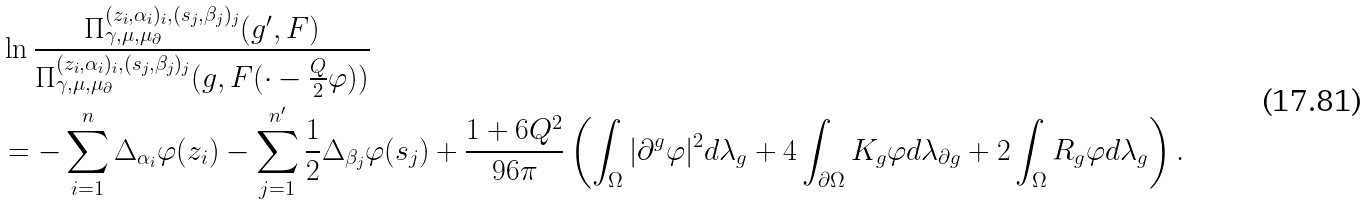<formula> <loc_0><loc_0><loc_500><loc_500>& \ln \frac { \Pi _ { \gamma , \mu , \mu _ { \partial } } ^ { ( z _ { i } , \alpha _ { i } ) _ { i } , ( s _ { j } , \beta _ { j } ) _ { j } } ( g ^ { \prime } , F ) } { \Pi _ { \gamma , \mu , \mu _ { \partial } } ^ { ( z _ { i } , \alpha _ { i } ) _ { i } , ( s _ { j } , \beta _ { j } ) _ { j } } ( g , F ( \cdot - \frac { Q } { 2 } \varphi ) ) } \\ & = - \sum _ { i = 1 } ^ { n } \Delta _ { \alpha _ { i } } \varphi ( z _ { i } ) - \sum _ { j = 1 } ^ { n ^ { \prime } } \frac { 1 } { 2 } \Delta _ { \beta _ { j } } \varphi ( s _ { j } ) + \frac { 1 + 6 Q ^ { 2 } } { 9 6 \pi } \left ( \int _ { \Omega } | \partial ^ { g } \varphi | ^ { 2 } d \lambda _ { g } + 4 \int _ { \partial \Omega } K _ { g } \varphi d \lambda _ { \partial g } + 2 \int _ { \Omega } R _ { g } \varphi d \lambda _ { g } \right ) .</formula> 